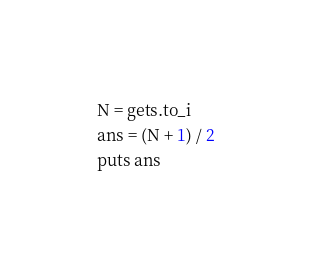Convert code to text. <code><loc_0><loc_0><loc_500><loc_500><_Ruby_>N = gets.to_i
ans = (N + 1) / 2
puts ans</code> 